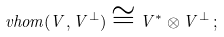Convert formula to latex. <formula><loc_0><loc_0><loc_500><loc_500>\ v h o m ( V , V ^ { \perp } ) \cong V ^ { * } \otimes V ^ { \perp } \, ;</formula> 